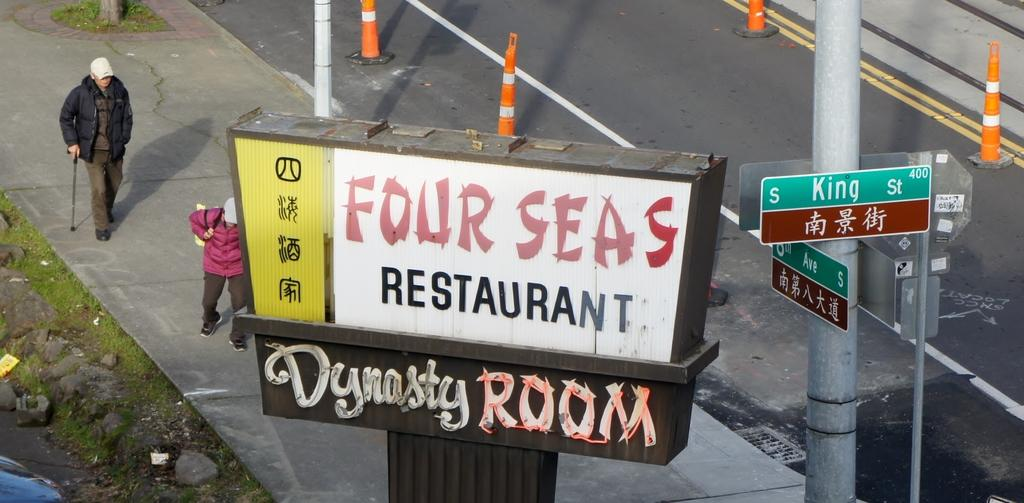<image>
Write a terse but informative summary of the picture. The Four Seas Restaurant's sign says it is where you'll find the Dynasty Room. 